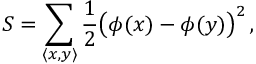Convert formula to latex. <formula><loc_0><loc_0><loc_500><loc_500>S = \sum _ { \langle x , y \rangle } { \frac { 1 } { 2 } } { \left ( } \phi ( x ) - \phi ( y ) { \right ) } ^ { 2 } \, ,</formula> 